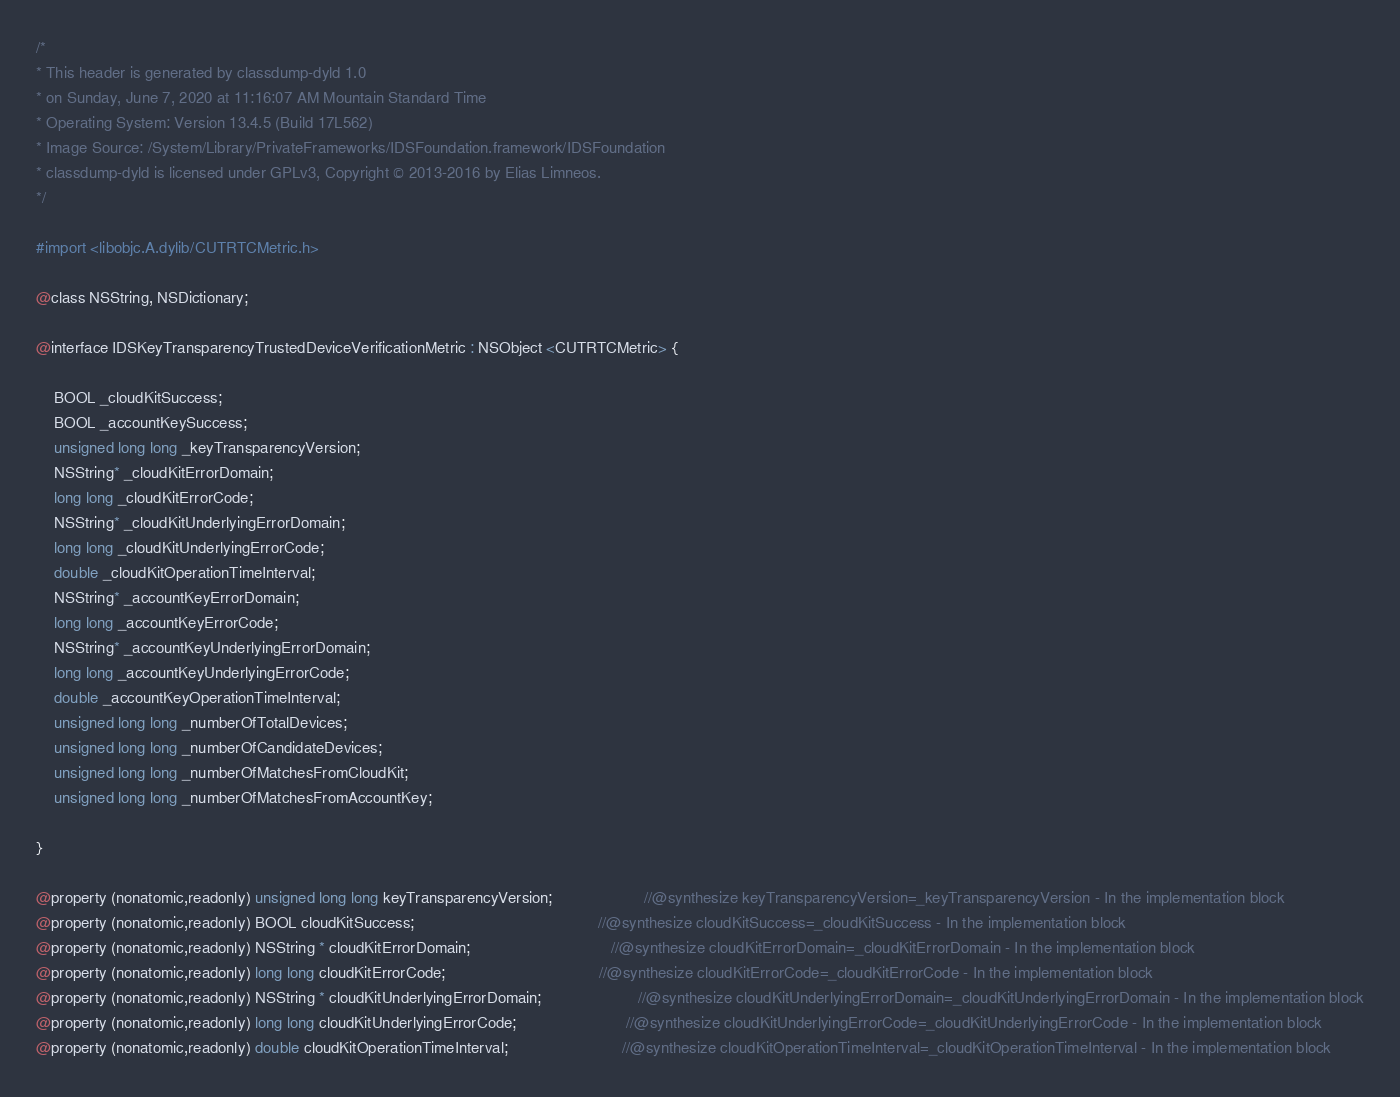<code> <loc_0><loc_0><loc_500><loc_500><_C_>/*
* This header is generated by classdump-dyld 1.0
* on Sunday, June 7, 2020 at 11:16:07 AM Mountain Standard Time
* Operating System: Version 13.4.5 (Build 17L562)
* Image Source: /System/Library/PrivateFrameworks/IDSFoundation.framework/IDSFoundation
* classdump-dyld is licensed under GPLv3, Copyright © 2013-2016 by Elias Limneos.
*/

#import <libobjc.A.dylib/CUTRTCMetric.h>

@class NSString, NSDictionary;

@interface IDSKeyTransparencyTrustedDeviceVerificationMetric : NSObject <CUTRTCMetric> {

	BOOL _cloudKitSuccess;
	BOOL _accountKeySuccess;
	unsigned long long _keyTransparencyVersion;
	NSString* _cloudKitErrorDomain;
	long long _cloudKitErrorCode;
	NSString* _cloudKitUnderlyingErrorDomain;
	long long _cloudKitUnderlyingErrorCode;
	double _cloudKitOperationTimeInterval;
	NSString* _accountKeyErrorDomain;
	long long _accountKeyErrorCode;
	NSString* _accountKeyUnderlyingErrorDomain;
	long long _accountKeyUnderlyingErrorCode;
	double _accountKeyOperationTimeInterval;
	unsigned long long _numberOfTotalDevices;
	unsigned long long _numberOfCandidateDevices;
	unsigned long long _numberOfMatchesFromCloudKit;
	unsigned long long _numberOfMatchesFromAccountKey;

}

@property (nonatomic,readonly) unsigned long long keyTransparencyVersion;                     //@synthesize keyTransparencyVersion=_keyTransparencyVersion - In the implementation block
@property (nonatomic,readonly) BOOL cloudKitSuccess;                                          //@synthesize cloudKitSuccess=_cloudKitSuccess - In the implementation block
@property (nonatomic,readonly) NSString * cloudKitErrorDomain;                                //@synthesize cloudKitErrorDomain=_cloudKitErrorDomain - In the implementation block
@property (nonatomic,readonly) long long cloudKitErrorCode;                                   //@synthesize cloudKitErrorCode=_cloudKitErrorCode - In the implementation block
@property (nonatomic,readonly) NSString * cloudKitUnderlyingErrorDomain;                      //@synthesize cloudKitUnderlyingErrorDomain=_cloudKitUnderlyingErrorDomain - In the implementation block
@property (nonatomic,readonly) long long cloudKitUnderlyingErrorCode;                         //@synthesize cloudKitUnderlyingErrorCode=_cloudKitUnderlyingErrorCode - In the implementation block
@property (nonatomic,readonly) double cloudKitOperationTimeInterval;                          //@synthesize cloudKitOperationTimeInterval=_cloudKitOperationTimeInterval - In the implementation block</code> 